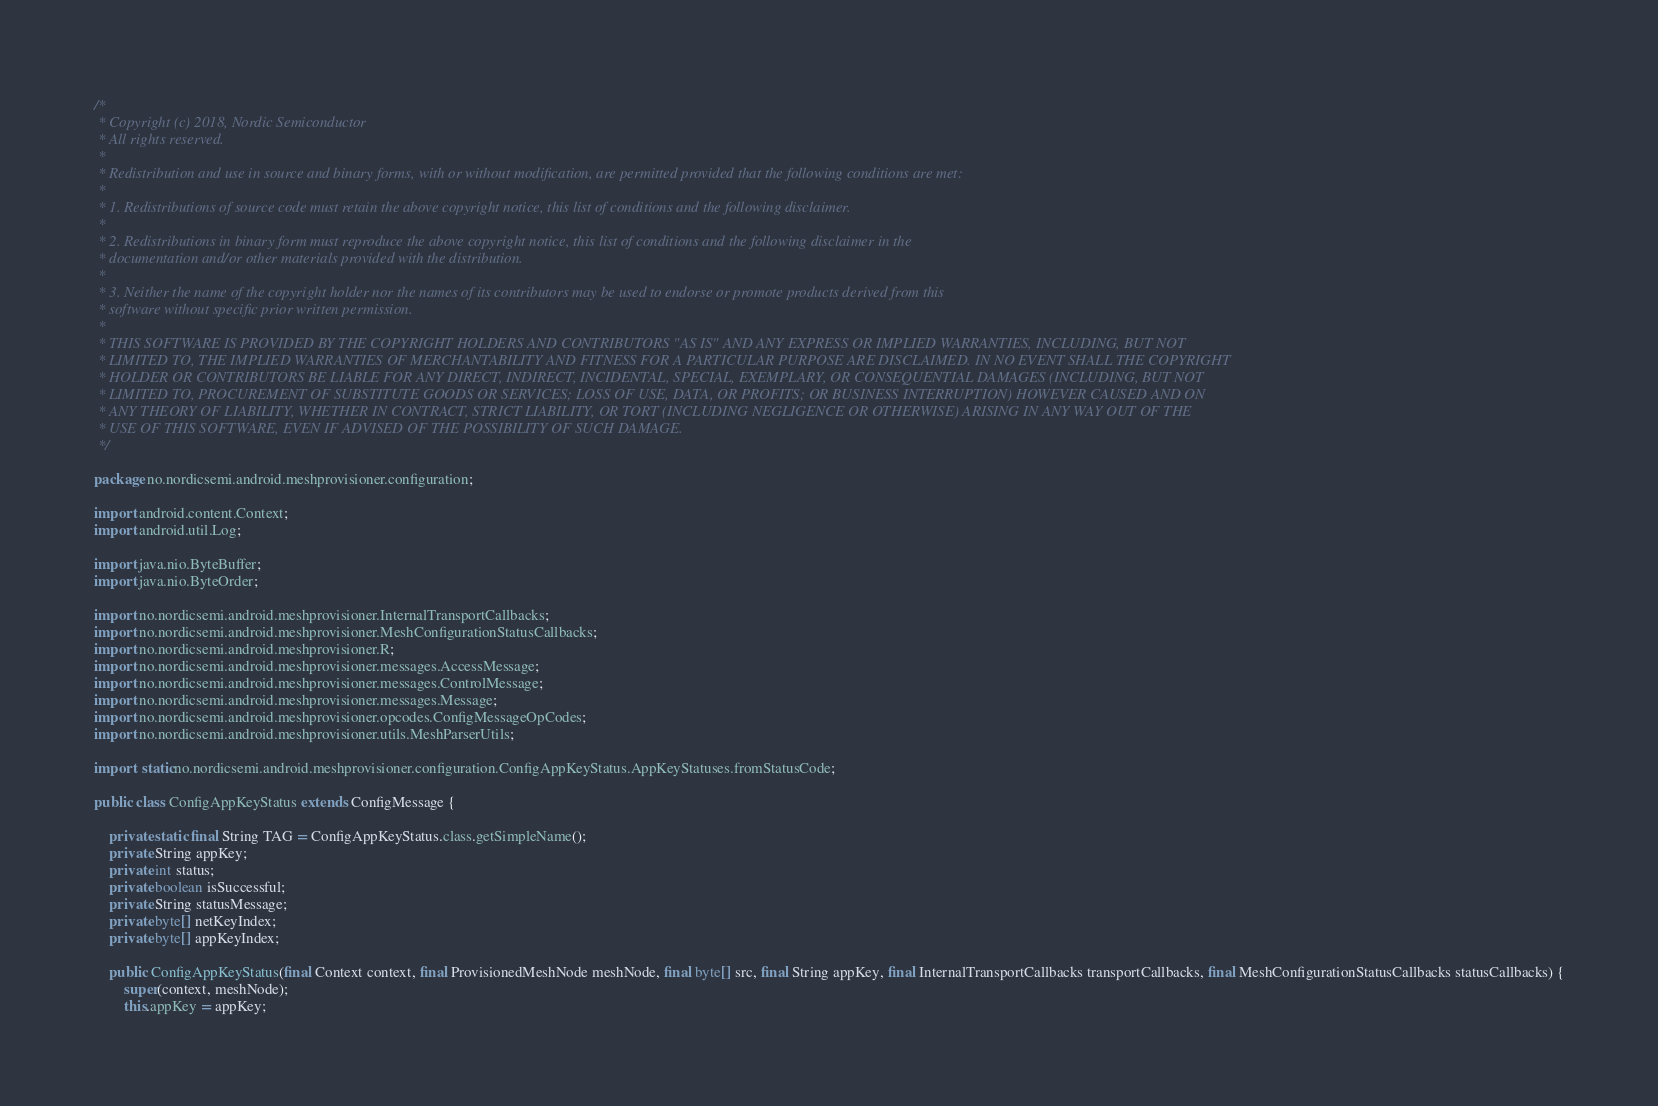Convert code to text. <code><loc_0><loc_0><loc_500><loc_500><_Java_>/*
 * Copyright (c) 2018, Nordic Semiconductor
 * All rights reserved.
 *
 * Redistribution and use in source and binary forms, with or without modification, are permitted provided that the following conditions are met:
 *
 * 1. Redistributions of source code must retain the above copyright notice, this list of conditions and the following disclaimer.
 *
 * 2. Redistributions in binary form must reproduce the above copyright notice, this list of conditions and the following disclaimer in the
 * documentation and/or other materials provided with the distribution.
 *
 * 3. Neither the name of the copyright holder nor the names of its contributors may be used to endorse or promote products derived from this
 * software without specific prior written permission.
 *
 * THIS SOFTWARE IS PROVIDED BY THE COPYRIGHT HOLDERS AND CONTRIBUTORS "AS IS" AND ANY EXPRESS OR IMPLIED WARRANTIES, INCLUDING, BUT NOT
 * LIMITED TO, THE IMPLIED WARRANTIES OF MERCHANTABILITY AND FITNESS FOR A PARTICULAR PURPOSE ARE DISCLAIMED. IN NO EVENT SHALL THE COPYRIGHT
 * HOLDER OR CONTRIBUTORS BE LIABLE FOR ANY DIRECT, INDIRECT, INCIDENTAL, SPECIAL, EXEMPLARY, OR CONSEQUENTIAL DAMAGES (INCLUDING, BUT NOT
 * LIMITED TO, PROCUREMENT OF SUBSTITUTE GOODS OR SERVICES; LOSS OF USE, DATA, OR PROFITS; OR BUSINESS INTERRUPTION) HOWEVER CAUSED AND ON
 * ANY THEORY OF LIABILITY, WHETHER IN CONTRACT, STRICT LIABILITY, OR TORT (INCLUDING NEGLIGENCE OR OTHERWISE) ARISING IN ANY WAY OUT OF THE
 * USE OF THIS SOFTWARE, EVEN IF ADVISED OF THE POSSIBILITY OF SUCH DAMAGE.
 */

package no.nordicsemi.android.meshprovisioner.configuration;

import android.content.Context;
import android.util.Log;

import java.nio.ByteBuffer;
import java.nio.ByteOrder;

import no.nordicsemi.android.meshprovisioner.InternalTransportCallbacks;
import no.nordicsemi.android.meshprovisioner.MeshConfigurationStatusCallbacks;
import no.nordicsemi.android.meshprovisioner.R;
import no.nordicsemi.android.meshprovisioner.messages.AccessMessage;
import no.nordicsemi.android.meshprovisioner.messages.ControlMessage;
import no.nordicsemi.android.meshprovisioner.messages.Message;
import no.nordicsemi.android.meshprovisioner.opcodes.ConfigMessageOpCodes;
import no.nordicsemi.android.meshprovisioner.utils.MeshParserUtils;

import static no.nordicsemi.android.meshprovisioner.configuration.ConfigAppKeyStatus.AppKeyStatuses.fromStatusCode;

public class ConfigAppKeyStatus extends ConfigMessage {

    private static final String TAG = ConfigAppKeyStatus.class.getSimpleName();
    private String appKey;
    private int status;
    private boolean isSuccessful;
    private String statusMessage;
    private byte[] netKeyIndex;
    private byte[] appKeyIndex;

    public ConfigAppKeyStatus(final Context context, final ProvisionedMeshNode meshNode, final byte[] src, final String appKey, final InternalTransportCallbacks transportCallbacks, final MeshConfigurationStatusCallbacks statusCallbacks) {
        super(context, meshNode);
        this.appKey = appKey;</code> 